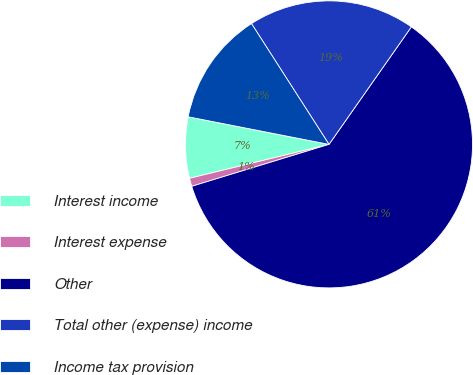Convert chart to OTSL. <chart><loc_0><loc_0><loc_500><loc_500><pie_chart><fcel>Interest income<fcel>Interest expense<fcel>Other<fcel>Total other (expense) income<fcel>Income tax provision<nl><fcel>6.88%<fcel>0.92%<fcel>60.55%<fcel>18.81%<fcel>12.84%<nl></chart> 